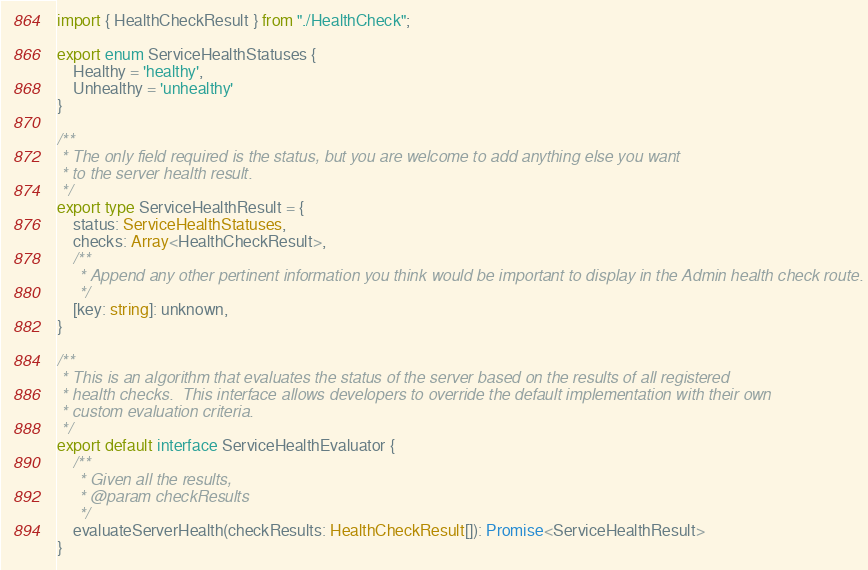<code> <loc_0><loc_0><loc_500><loc_500><_TypeScript_>import { HealthCheckResult } from "./HealthCheck";

export enum ServiceHealthStatuses {
    Healthy = 'healthy',
    Unhealthy = 'unhealthy'
}

/**
 * The only field required is the status, but you are welcome to add anything else you want
 * to the server health result.
 */
export type ServiceHealthResult = {
    status: ServiceHealthStatuses,
    checks: Array<HealthCheckResult>,
    /**
     * Append any other pertinent information you think would be important to display in the Admin health check route.
     */
    [key: string]: unknown,
}

/**
 * This is an algorithm that evaluates the status of the server based on the results of all registered
 * health checks.  This interface allows developers to override the default implementation with their own
 * custom evaluation criteria.
 */
export default interface ServiceHealthEvaluator {
    /**
     * Given all the results,
     * @param checkResults
     */
    evaluateServerHealth(checkResults: HealthCheckResult[]): Promise<ServiceHealthResult>
}
</code> 